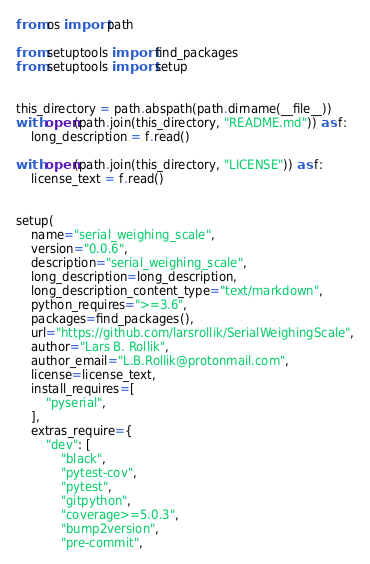<code> <loc_0><loc_0><loc_500><loc_500><_Python_>from os import path

from setuptools import find_packages
from setuptools import setup


this_directory = path.abspath(path.dirname(__file__))
with open(path.join(this_directory, "README.md")) as f:
    long_description = f.read()

with open(path.join(this_directory, "LICENSE")) as f:
    license_text = f.read()


setup(
    name="serial_weighing_scale",
    version="0.0.6",
    description="serial_weighing_scale",
    long_description=long_description,
    long_description_content_type="text/markdown",
    python_requires=">=3.6",
    packages=find_packages(),
    url="https://github.com/larsrollik/SerialWeighingScale",
    author="Lars B. Rollik",
    author_email="L.B.Rollik@protonmail.com",
    license=license_text,
    install_requires=[
        "pyserial",
    ],
    extras_require={
        "dev": [
            "black",
            "pytest-cov",
            "pytest",
            "gitpython",
            "coverage>=5.0.3",
            "bump2version",
            "pre-commit",</code> 